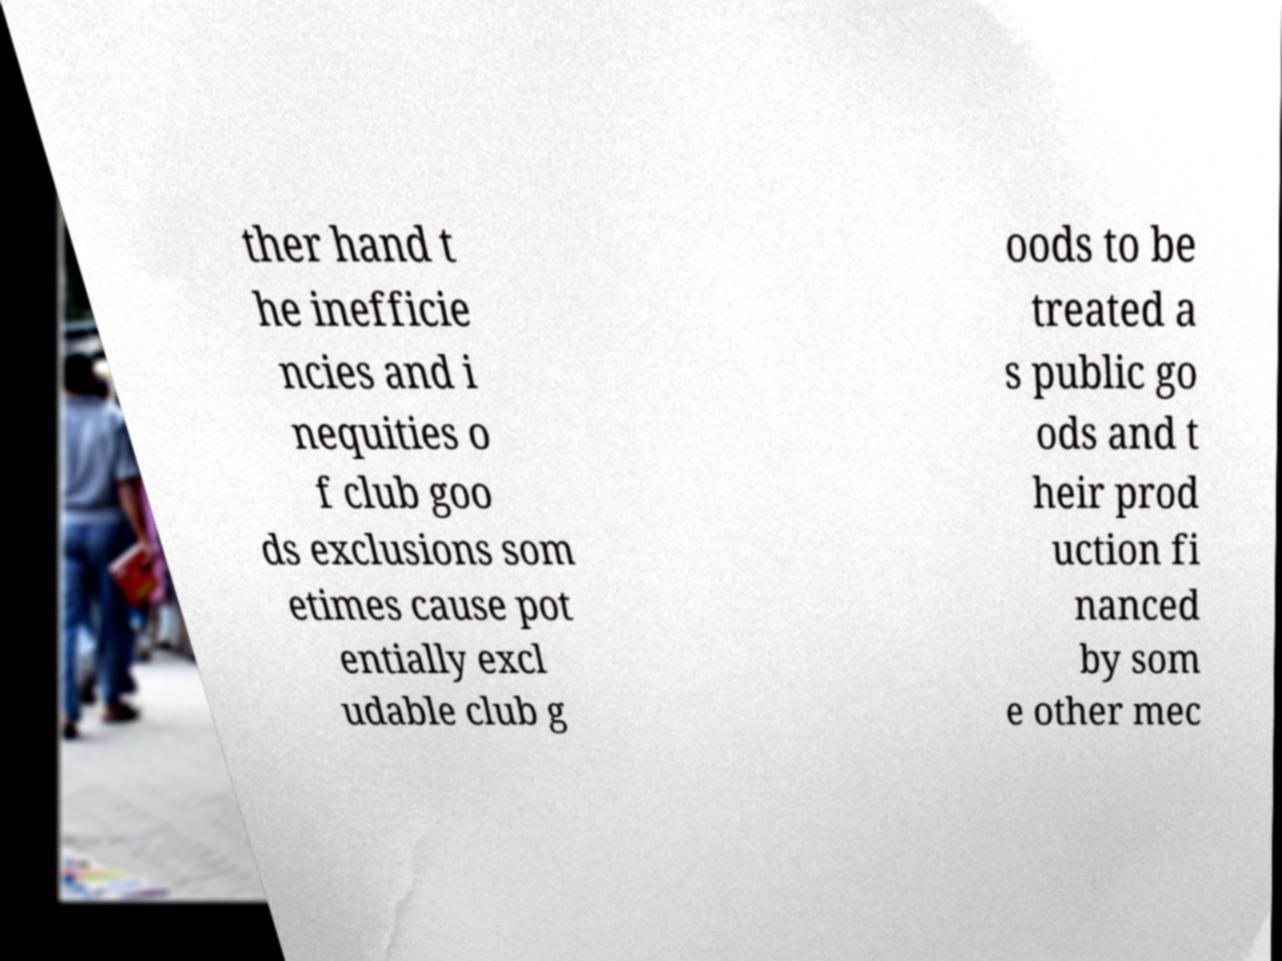Could you extract and type out the text from this image? ther hand t he inefficie ncies and i nequities o f club goo ds exclusions som etimes cause pot entially excl udable club g oods to be treated a s public go ods and t heir prod uction fi nanced by som e other mec 